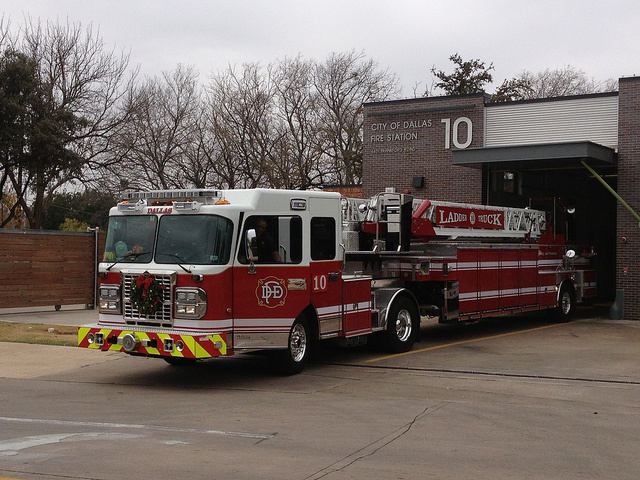Describe the objects in this image and their specific colors. I can see truck in lightgray, black, maroon, gray, and darkgray tones and people in lavender, black, gray, and darkgray tones in this image. 